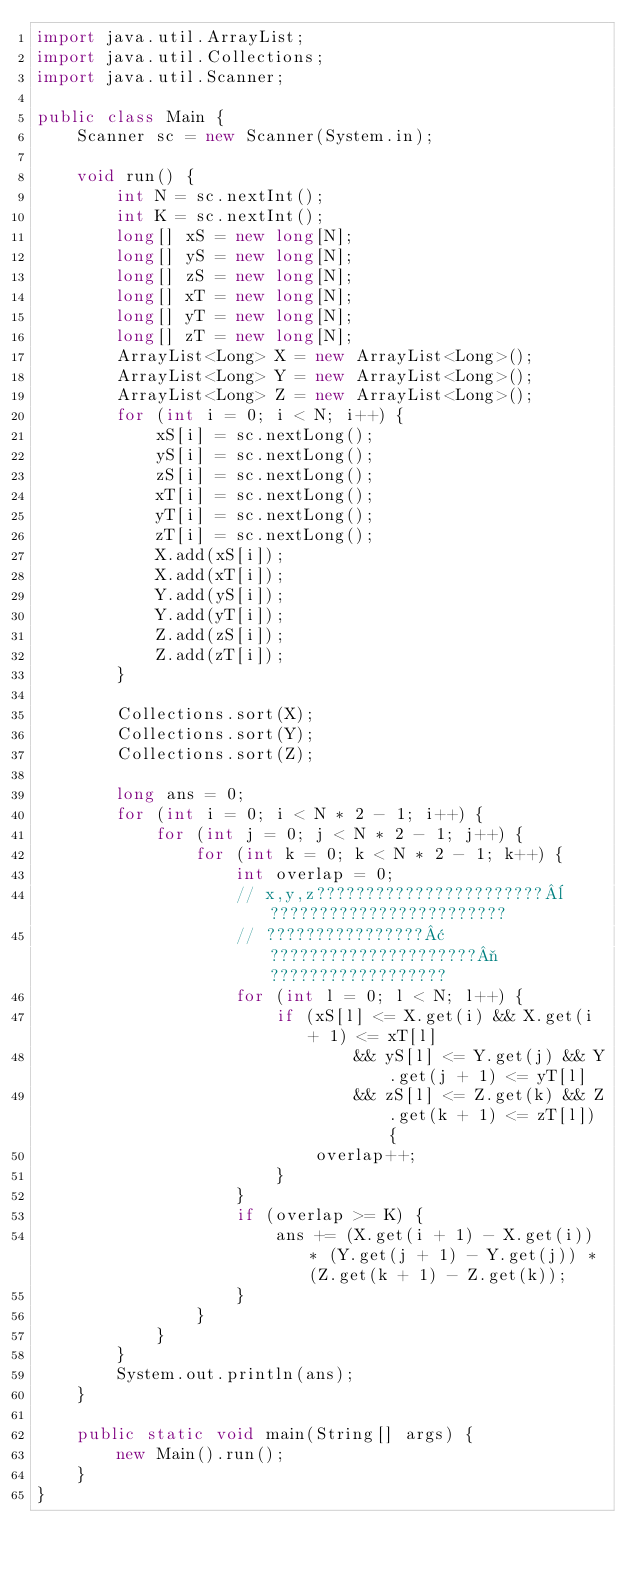<code> <loc_0><loc_0><loc_500><loc_500><_Java_>import java.util.ArrayList;
import java.util.Collections;
import java.util.Scanner;

public class Main {
	Scanner sc = new Scanner(System.in);

	void run() {
		int N = sc.nextInt();
		int K = sc.nextInt();
		long[] xS = new long[N];
		long[] yS = new long[N];
		long[] zS = new long[N];
		long[] xT = new long[N];
		long[] yT = new long[N];
		long[] zT = new long[N];
		ArrayList<Long> X = new ArrayList<Long>();
		ArrayList<Long> Y = new ArrayList<Long>();
		ArrayList<Long> Z = new ArrayList<Long>();
		for (int i = 0; i < N; i++) {
			xS[i] = sc.nextLong();
			yS[i] = sc.nextLong();
			zS[i] = sc.nextLong();
			xT[i] = sc.nextLong();
			yT[i] = sc.nextLong();
			zT[i] = sc.nextLong();
			X.add(xS[i]);
			X.add(xT[i]);
			Y.add(yS[i]);
			Y.add(yT[i]);
			Z.add(zS[i]);
			Z.add(zT[i]);
		}

		Collections.sort(X);
		Collections.sort(Y);
		Collections.sort(Z);

		long ans = 0;
		for (int i = 0; i < N * 2 - 1; i++) {
			for (int j = 0; j < N * 2 - 1; j++) {
				for (int k = 0; k < N * 2 - 1; k++) {
					int overlap = 0;
					// x,y,z???????????????????????¨????????????????????????
					// ????????????????¢?????????????????????¬??????????????????
					for (int l = 0; l < N; l++) {
						if (xS[l] <= X.get(i) && X.get(i + 1) <= xT[l]
								&& yS[l] <= Y.get(j) && Y.get(j + 1) <= yT[l]
								&& zS[l] <= Z.get(k) && Z.get(k + 1) <= zT[l]) {
							overlap++;
						}
					}
					if (overlap >= K) {
						ans += (X.get(i + 1) - X.get(i)) * (Y.get(j + 1) - Y.get(j)) * (Z.get(k + 1) - Z.get(k));
					}
				}
			}
		}
		System.out.println(ans);
	}

	public static void main(String[] args) {
		new Main().run();
	}
}</code> 